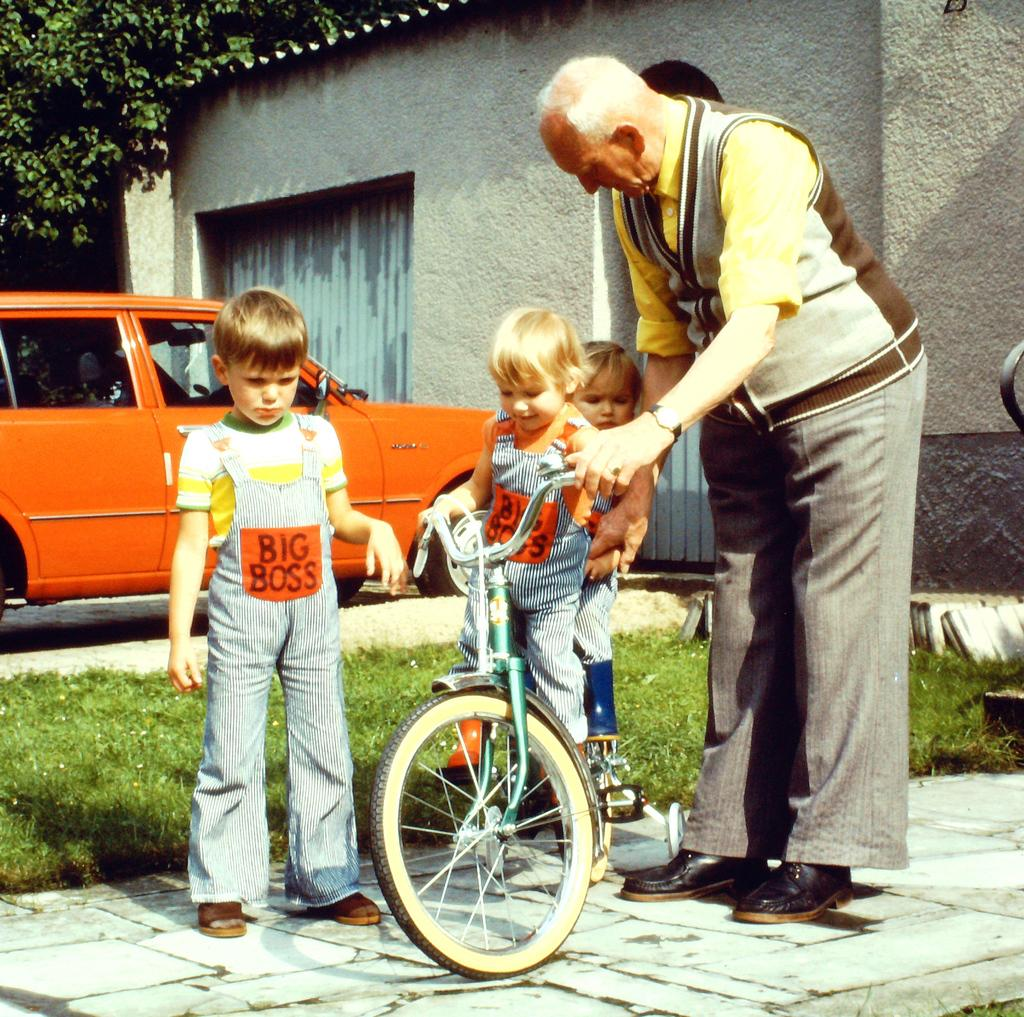How many children are on the bicycle in the image? There are two children on the bicycle in the image. What is the position of the third child in the image? There is a child standing beside the bicycle. Who else is standing beside the bicycle? An old man is standing beside the bicycle. What can be seen in the background of the image? There is a car, a building, and trees in the background of the image. What type of bait is the child holding in the image? There is no bait present in the image; the children are on a bicycle and there is no indication of fishing or bait. 